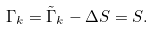Convert formula to latex. <formula><loc_0><loc_0><loc_500><loc_500>\Gamma _ { k } = \tilde { \Gamma } _ { k } - \Delta S = S .</formula> 